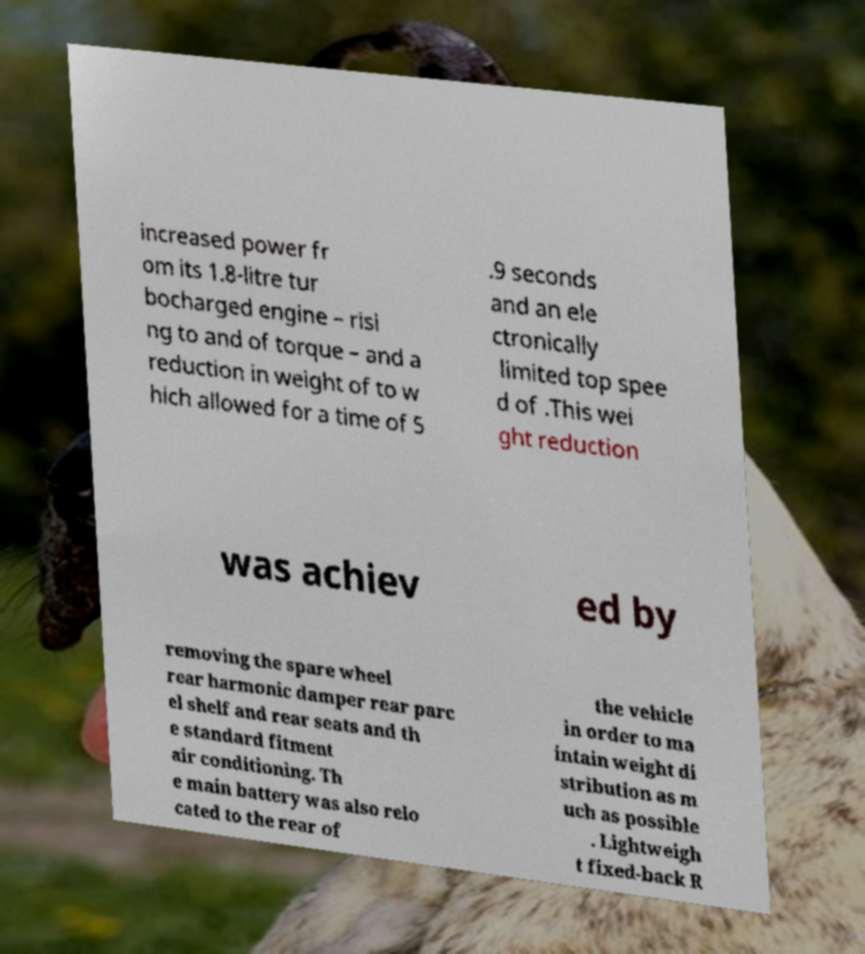Please identify and transcribe the text found in this image. increased power fr om its 1.8-litre tur bocharged engine – risi ng to and of torque – and a reduction in weight of to w hich allowed for a time of 5 .9 seconds and an ele ctronically limited top spee d of .This wei ght reduction was achiev ed by removing the spare wheel rear harmonic damper rear parc el shelf and rear seats and th e standard fitment air conditioning. Th e main battery was also relo cated to the rear of the vehicle in order to ma intain weight di stribution as m uch as possible . Lightweigh t fixed-back R 